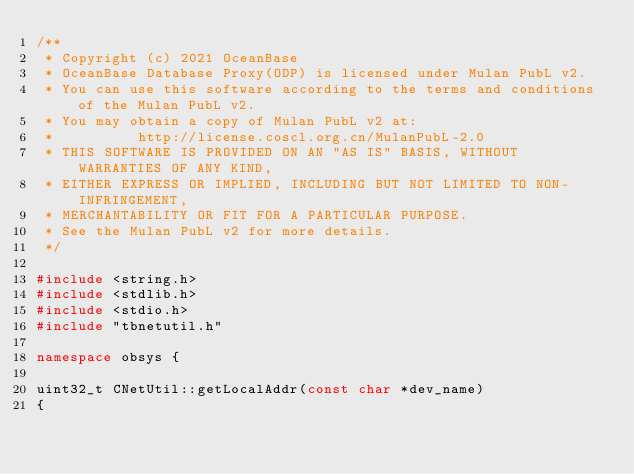Convert code to text. <code><loc_0><loc_0><loc_500><loc_500><_C++_>/**
 * Copyright (c) 2021 OceanBase
 * OceanBase Database Proxy(ODP) is licensed under Mulan PubL v2.
 * You can use this software according to the terms and conditions of the Mulan PubL v2.
 * You may obtain a copy of Mulan PubL v2 at:
 *          http://license.coscl.org.cn/MulanPubL-2.0
 * THIS SOFTWARE IS PROVIDED ON AN "AS IS" BASIS, WITHOUT WARRANTIES OF ANY KIND,
 * EITHER EXPRESS OR IMPLIED, INCLUDING BUT NOT LIMITED TO NON-INFRINGEMENT,
 * MERCHANTABILITY OR FIT FOR A PARTICULAR PURPOSE.
 * See the Mulan PubL v2 for more details.
 */

#include <string.h>
#include <stdlib.h>
#include <stdio.h>
#include "tbnetutil.h"

namespace obsys {

uint32_t CNetUtil::getLocalAddr(const char *dev_name)
{</code> 